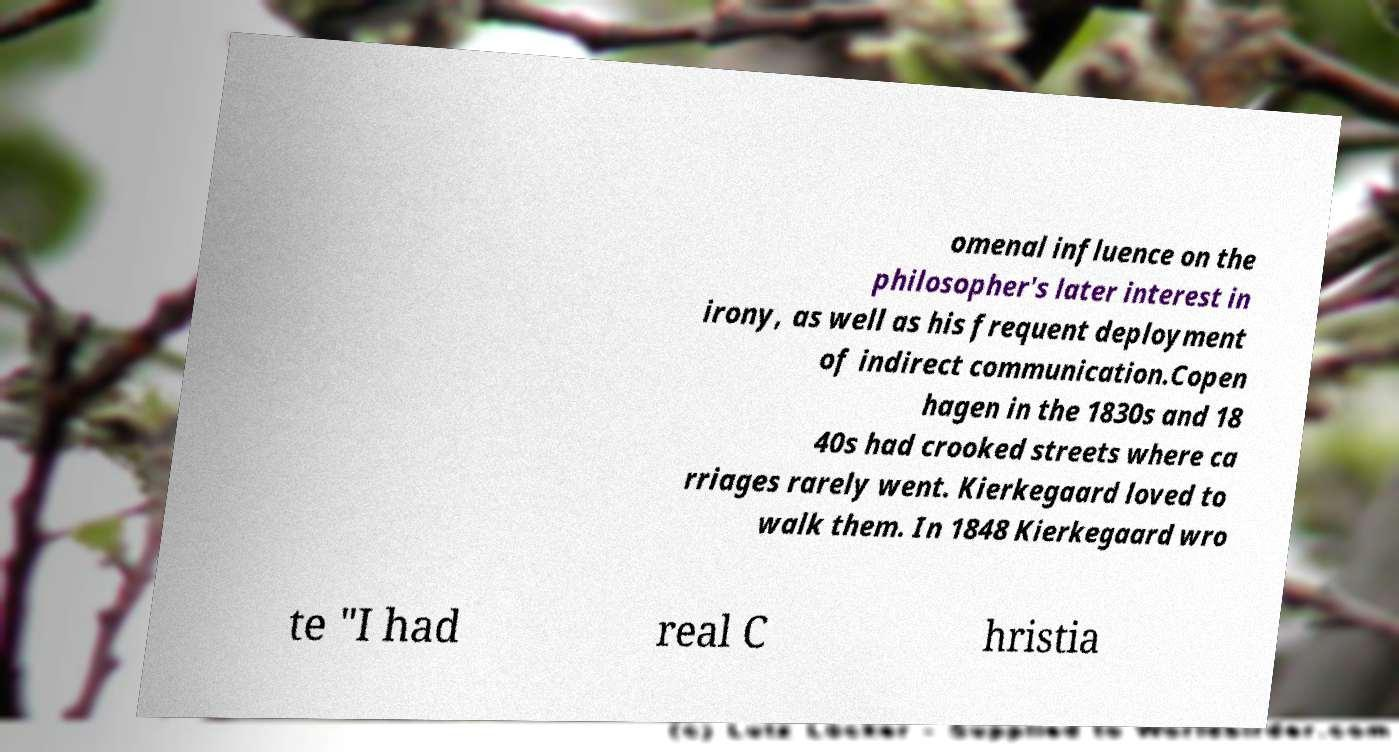There's text embedded in this image that I need extracted. Can you transcribe it verbatim? omenal influence on the philosopher's later interest in irony, as well as his frequent deployment of indirect communication.Copen hagen in the 1830s and 18 40s had crooked streets where ca rriages rarely went. Kierkegaard loved to walk them. In 1848 Kierkegaard wro te "I had real C hristia 